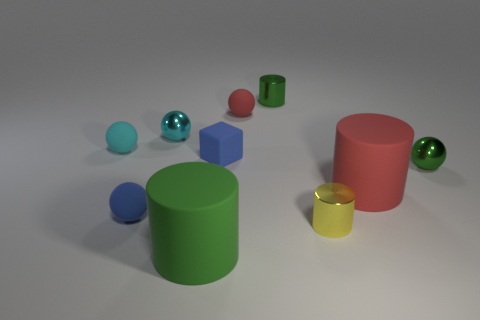There is a cylinder that is the same size as the yellow object; what color is it?
Give a very brief answer. Green. How many tiny objects are red things or cyan spheres?
Provide a short and direct response. 3. Is the number of green matte objects behind the red rubber cylinder greater than the number of small blue rubber objects behind the small blue ball?
Your response must be concise. No. The rubber sphere that is the same color as the tiny matte block is what size?
Provide a succinct answer. Small. What number of other objects are the same size as the yellow shiny cylinder?
Ensure brevity in your answer.  7. Do the cylinder that is right of the yellow thing and the tiny yellow thing have the same material?
Give a very brief answer. No. How many other things are there of the same color as the block?
Provide a short and direct response. 1. What number of other objects are there of the same shape as the large green thing?
Your answer should be very brief. 3. Does the big matte thing in front of the small yellow metal cylinder have the same shape as the tiny object that is in front of the blue sphere?
Your response must be concise. Yes. Are there an equal number of large green objects that are right of the large red matte cylinder and cyan metal objects that are in front of the blue ball?
Your answer should be compact. Yes. 